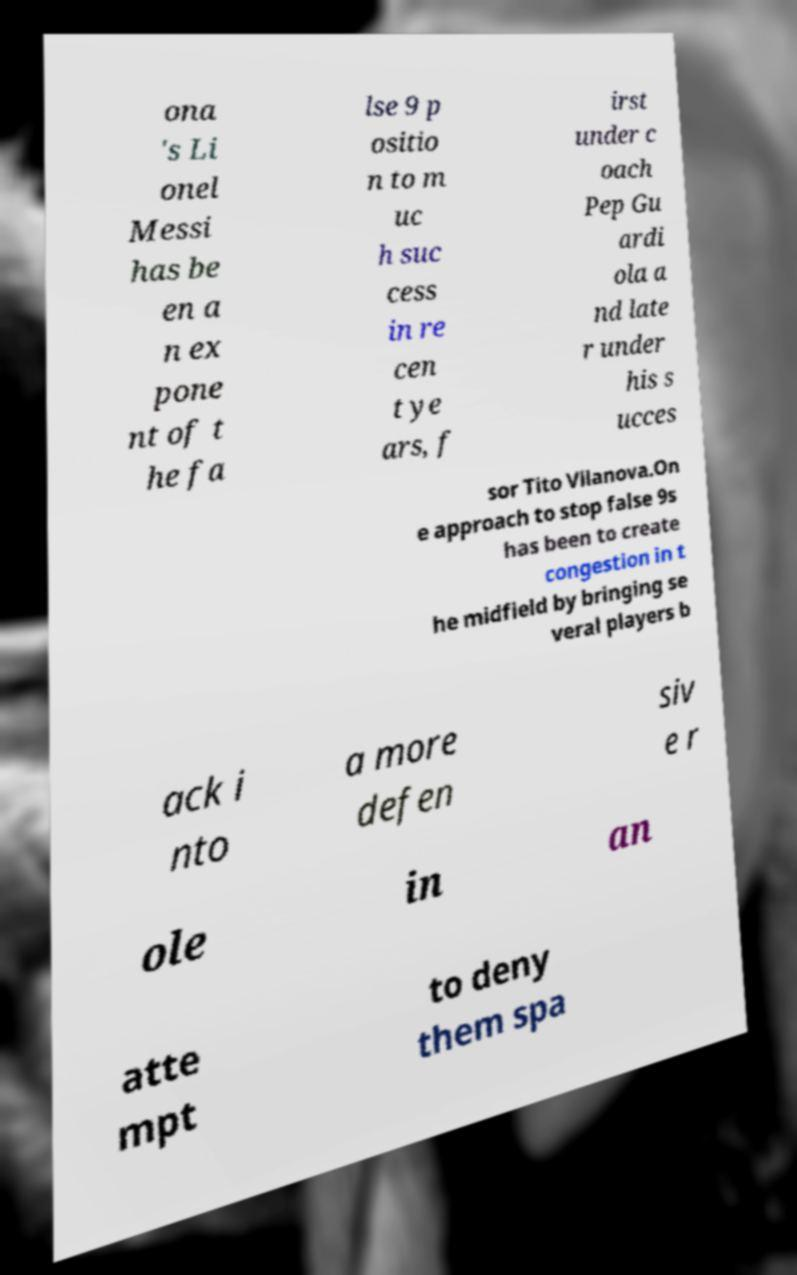Can you detail how Lionel Messi's playing style as a 'false 9' has evolved under different coaches according to the text? The text references Lionel Messi's evolution under coaches such as Pep Guardiola and later Tito Vilanova. Under Guardiola, Messi's role as a 'false 9' became prominent, exploiting spaces and creating scoring opportunities, whereas Vilanova continued this approach with slight adaptations to team dynamics and opposition strategies. How did opposition teams adjust to Messi's role under these coaches? Opposition teams adjusted to Messi's 'false 9' role primarily by reinforcing their midfield and defensive alignments, aiming to reduce his influence on the game by cutting off the supply channels and limiting his space to maneuver. 